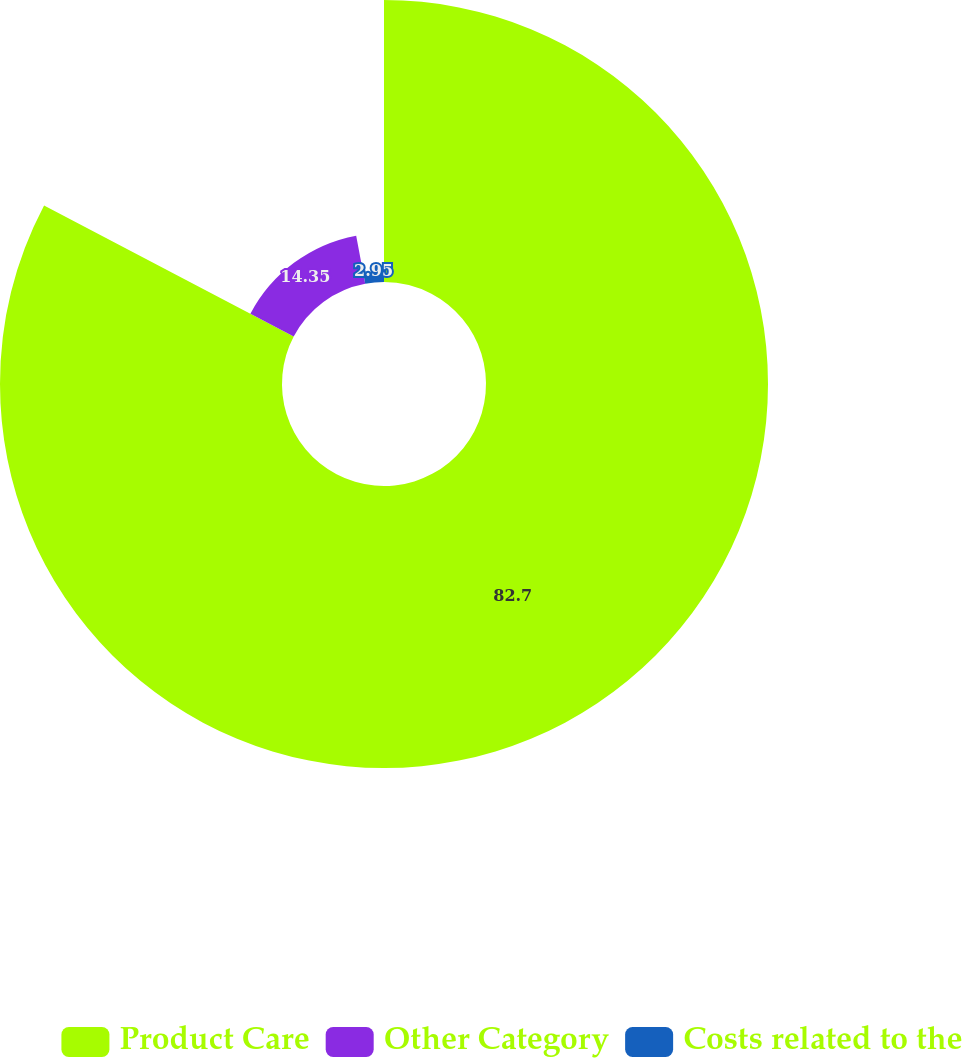Convert chart. <chart><loc_0><loc_0><loc_500><loc_500><pie_chart><fcel>Product Care<fcel>Other Category<fcel>Costs related to the<nl><fcel>82.7%<fcel>14.35%<fcel>2.95%<nl></chart> 